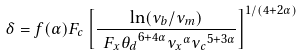Convert formula to latex. <formula><loc_0><loc_0><loc_500><loc_500>\delta = f ( \alpha ) F _ { c } \left [ { \frac { { \ln ( { \nu } _ { b } / { \nu } _ { m } ) } } { { \ F _ { x } { \theta _ { d } } ^ { 6 + 4 \alpha } { { \nu } _ { x } } ^ { \alpha } { { \nu } _ { c } } ^ { 5 + 3 \alpha } } } } \right ] ^ { 1 / { ( 4 + 2 \alpha ) } }</formula> 